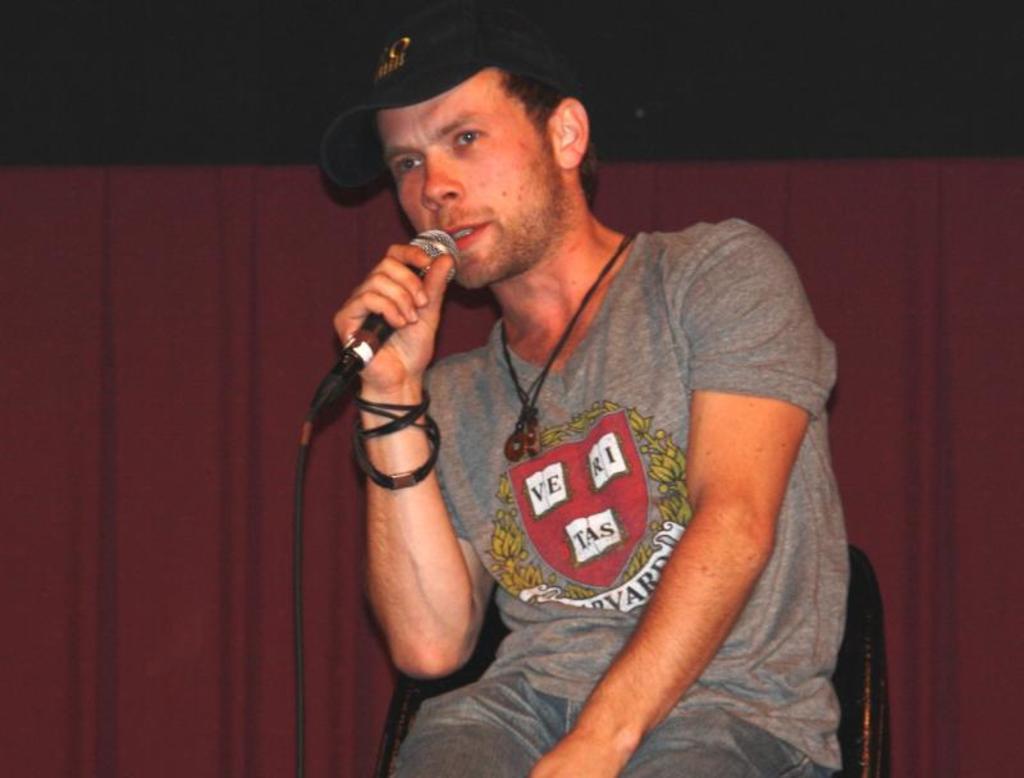Can you describe this image briefly? In this image, in the middle there is a man sitting on the chair and he is holding a microphone which is in black color and he is speaking in a microphone, in the background there is a red color curtain. 